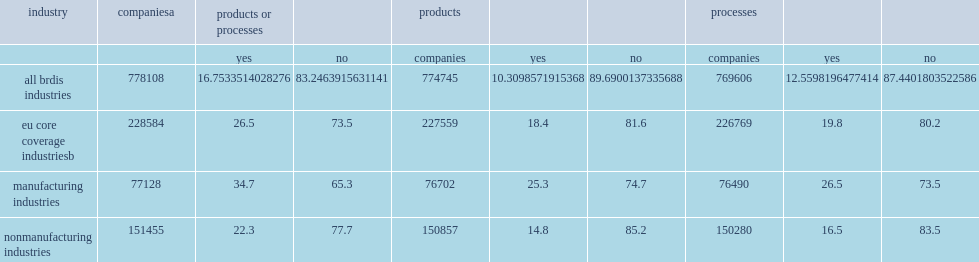How many percent of u.s. firms with 10 or more employees in the core coverage nonmanufacturing industries reported product or process innovations? 22.3. How many percent of u.s. manufacturers with 10 or more employees reported product or process innovations? 34.7. 